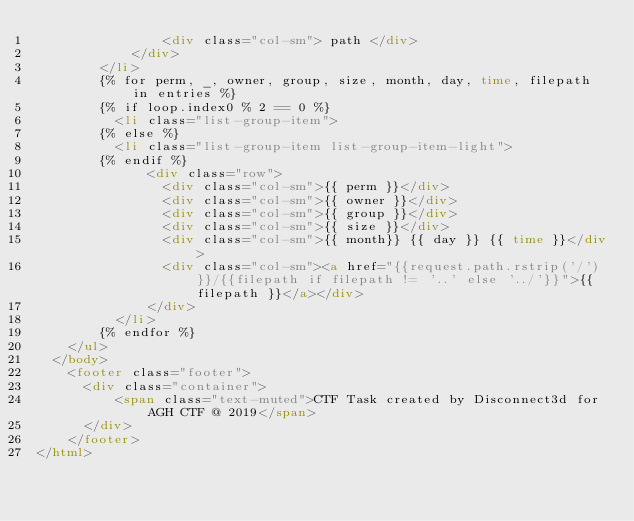<code> <loc_0><loc_0><loc_500><loc_500><_HTML_>                <div class="col-sm"> path </div>
            </div>
        </li>
        {% for perm, _, owner, group, size, month, day, time, filepath in entries %}
        {% if loop.index0 % 2 == 0 %}
          <li class="list-group-item">
        {% else %}
          <li class="list-group-item list-group-item-light">
        {% endif %}
              <div class="row">
                <div class="col-sm">{{ perm }}</div>
                <div class="col-sm">{{ owner }}</div>
                <div class="col-sm">{{ group }}</div>
                <div class="col-sm">{{ size }}</div>
                <div class="col-sm">{{ month}} {{ day }} {{ time }}</div>
                <div class="col-sm"><a href="{{request.path.rstrip('/')}}/{{filepath if filepath != '..' else '../'}}">{{ filepath }}</a></div>
              </div>
          </li>
        {% endfor %}
    </ul>
  </body>
    <footer class="footer">
      <div class="container">
          <span class="text-muted">CTF Task created by Disconnect3d for AGH CTF @ 2019</span>
      </div>
    </footer>
</html>
</code> 